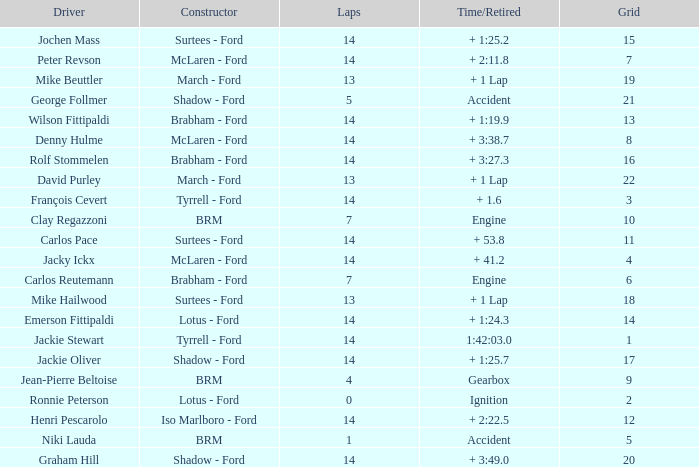What grad has a Time/Retired of + 1:24.3? 14.0. Could you parse the entire table? {'header': ['Driver', 'Constructor', 'Laps', 'Time/Retired', 'Grid'], 'rows': [['Jochen Mass', 'Surtees - Ford', '14', '+ 1:25.2', '15'], ['Peter Revson', 'McLaren - Ford', '14', '+ 2:11.8', '7'], ['Mike Beuttler', 'March - Ford', '13', '+ 1 Lap', '19'], ['George Follmer', 'Shadow - Ford', '5', 'Accident', '21'], ['Wilson Fittipaldi', 'Brabham - Ford', '14', '+ 1:19.9', '13'], ['Denny Hulme', 'McLaren - Ford', '14', '+ 3:38.7', '8'], ['Rolf Stommelen', 'Brabham - Ford', '14', '+ 3:27.3', '16'], ['David Purley', 'March - Ford', '13', '+ 1 Lap', '22'], ['François Cevert', 'Tyrrell - Ford', '14', '+ 1.6', '3'], ['Clay Regazzoni', 'BRM', '7', 'Engine', '10'], ['Carlos Pace', 'Surtees - Ford', '14', '+ 53.8', '11'], ['Jacky Ickx', 'McLaren - Ford', '14', '+ 41.2', '4'], ['Carlos Reutemann', 'Brabham - Ford', '7', 'Engine', '6'], ['Mike Hailwood', 'Surtees - Ford', '13', '+ 1 Lap', '18'], ['Emerson Fittipaldi', 'Lotus - Ford', '14', '+ 1:24.3', '14'], ['Jackie Stewart', 'Tyrrell - Ford', '14', '1:42:03.0', '1'], ['Jackie Oliver', 'Shadow - Ford', '14', '+ 1:25.7', '17'], ['Jean-Pierre Beltoise', 'BRM', '4', 'Gearbox', '9'], ['Ronnie Peterson', 'Lotus - Ford', '0', 'Ignition', '2'], ['Henri Pescarolo', 'Iso Marlboro - Ford', '14', '+ 2:22.5', '12'], ['Niki Lauda', 'BRM', '1', 'Accident', '5'], ['Graham Hill', 'Shadow - Ford', '14', '+ 3:49.0', '20']]} 